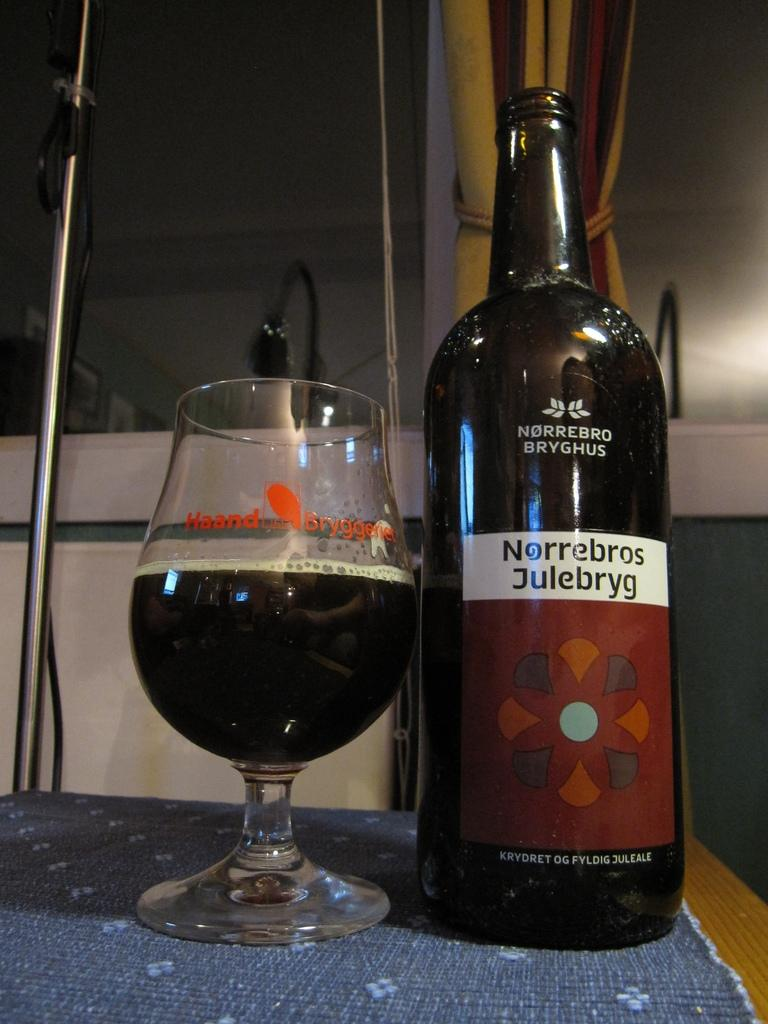Provide a one-sentence caption for the provided image. A bottle of Norrebros Julebryg is on a table next to a glass. 